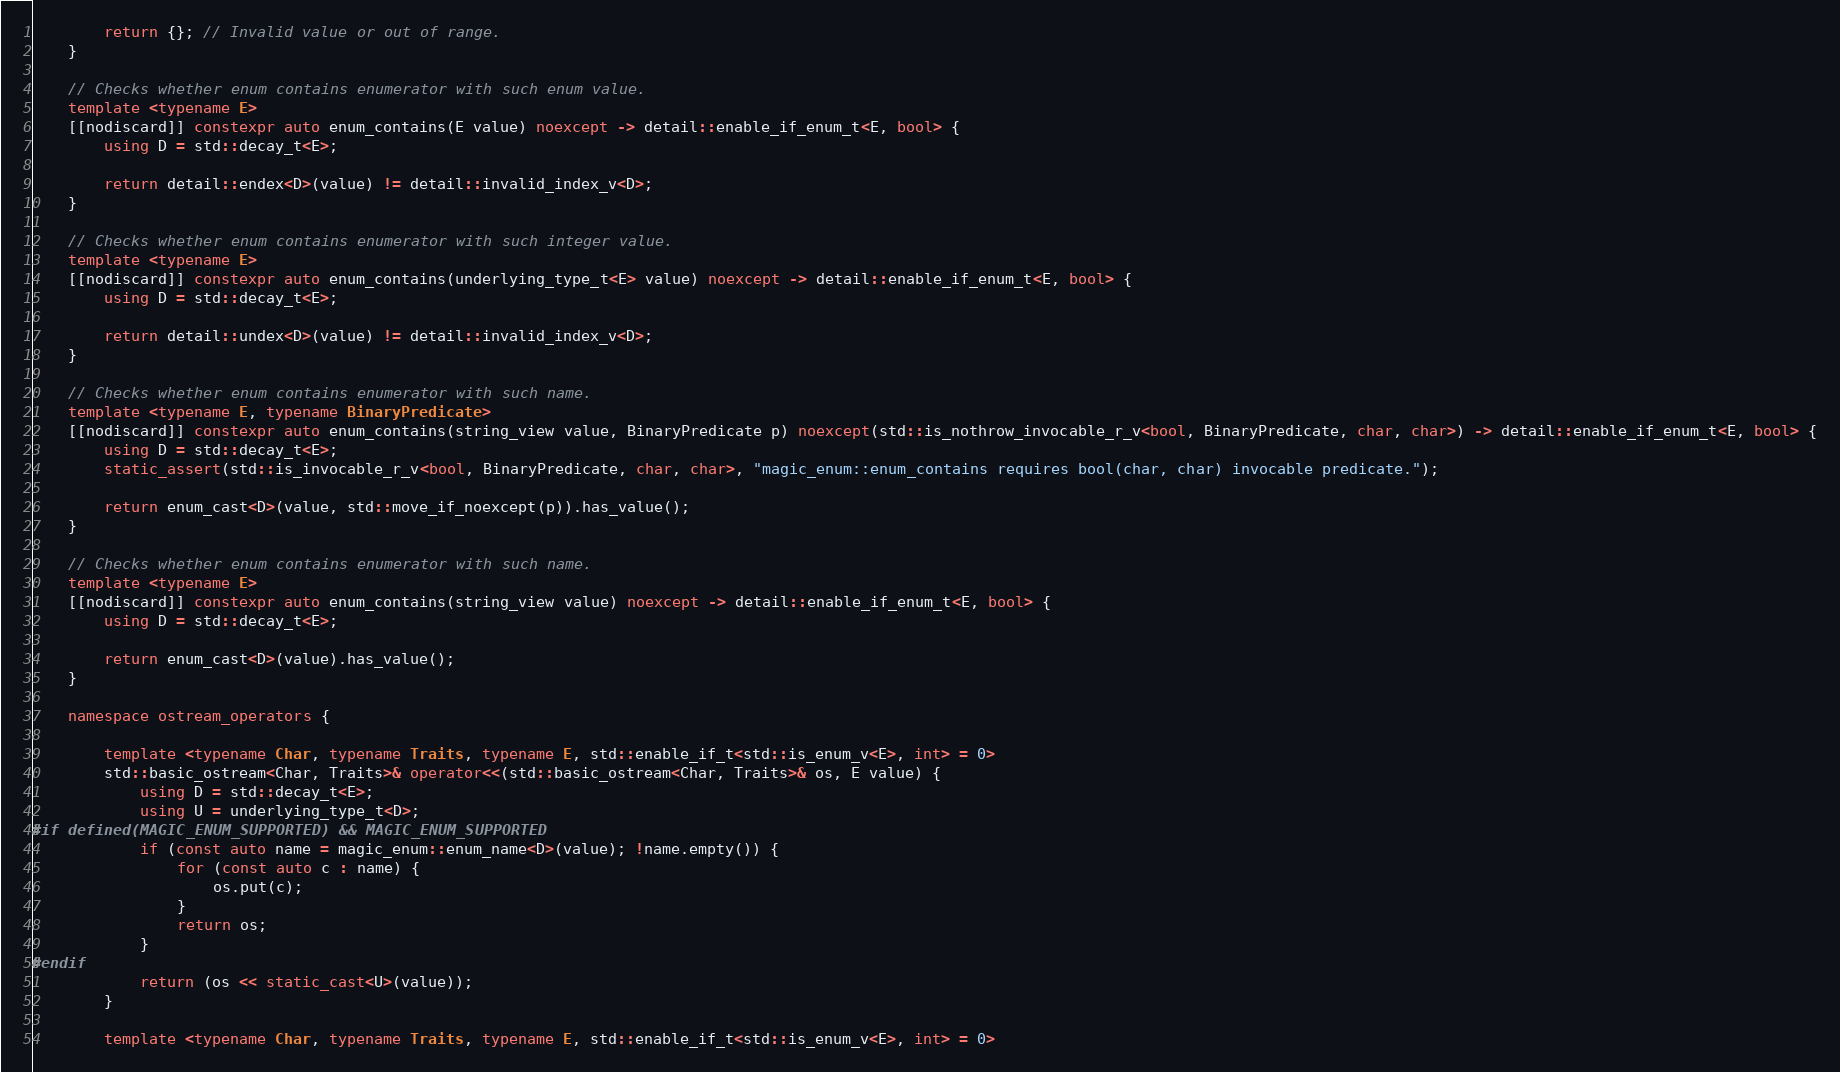Convert code to text. <code><loc_0><loc_0><loc_500><loc_500><_C++_>        return {}; // Invalid value or out of range.
    }

    // Checks whether enum contains enumerator with such enum value.
    template <typename E>
    [[nodiscard]] constexpr auto enum_contains(E value) noexcept -> detail::enable_if_enum_t<E, bool> {
        using D = std::decay_t<E>;

        return detail::endex<D>(value) != detail::invalid_index_v<D>;
    }

    // Checks whether enum contains enumerator with such integer value.
    template <typename E>
    [[nodiscard]] constexpr auto enum_contains(underlying_type_t<E> value) noexcept -> detail::enable_if_enum_t<E, bool> {
        using D = std::decay_t<E>;

        return detail::undex<D>(value) != detail::invalid_index_v<D>;
    }

    // Checks whether enum contains enumerator with such name.
    template <typename E, typename BinaryPredicate>
    [[nodiscard]] constexpr auto enum_contains(string_view value, BinaryPredicate p) noexcept(std::is_nothrow_invocable_r_v<bool, BinaryPredicate, char, char>) -> detail::enable_if_enum_t<E, bool> {
        using D = std::decay_t<E>;
        static_assert(std::is_invocable_r_v<bool, BinaryPredicate, char, char>, "magic_enum::enum_contains requires bool(char, char) invocable predicate.");

        return enum_cast<D>(value, std::move_if_noexcept(p)).has_value();
    }

    // Checks whether enum contains enumerator with such name.
    template <typename E>
    [[nodiscard]] constexpr auto enum_contains(string_view value) noexcept -> detail::enable_if_enum_t<E, bool> {
        using D = std::decay_t<E>;

        return enum_cast<D>(value).has_value();
    }

    namespace ostream_operators {

        template <typename Char, typename Traits, typename E, std::enable_if_t<std::is_enum_v<E>, int> = 0>
        std::basic_ostream<Char, Traits>& operator<<(std::basic_ostream<Char, Traits>& os, E value) {
            using D = std::decay_t<E>;
            using U = underlying_type_t<D>;
#if defined(MAGIC_ENUM_SUPPORTED) && MAGIC_ENUM_SUPPORTED
            if (const auto name = magic_enum::enum_name<D>(value); !name.empty()) {
                for (const auto c : name) {
                    os.put(c);
                }
                return os;
            }
#endif
            return (os << static_cast<U>(value));
        }

        template <typename Char, typename Traits, typename E, std::enable_if_t<std::is_enum_v<E>, int> = 0></code> 